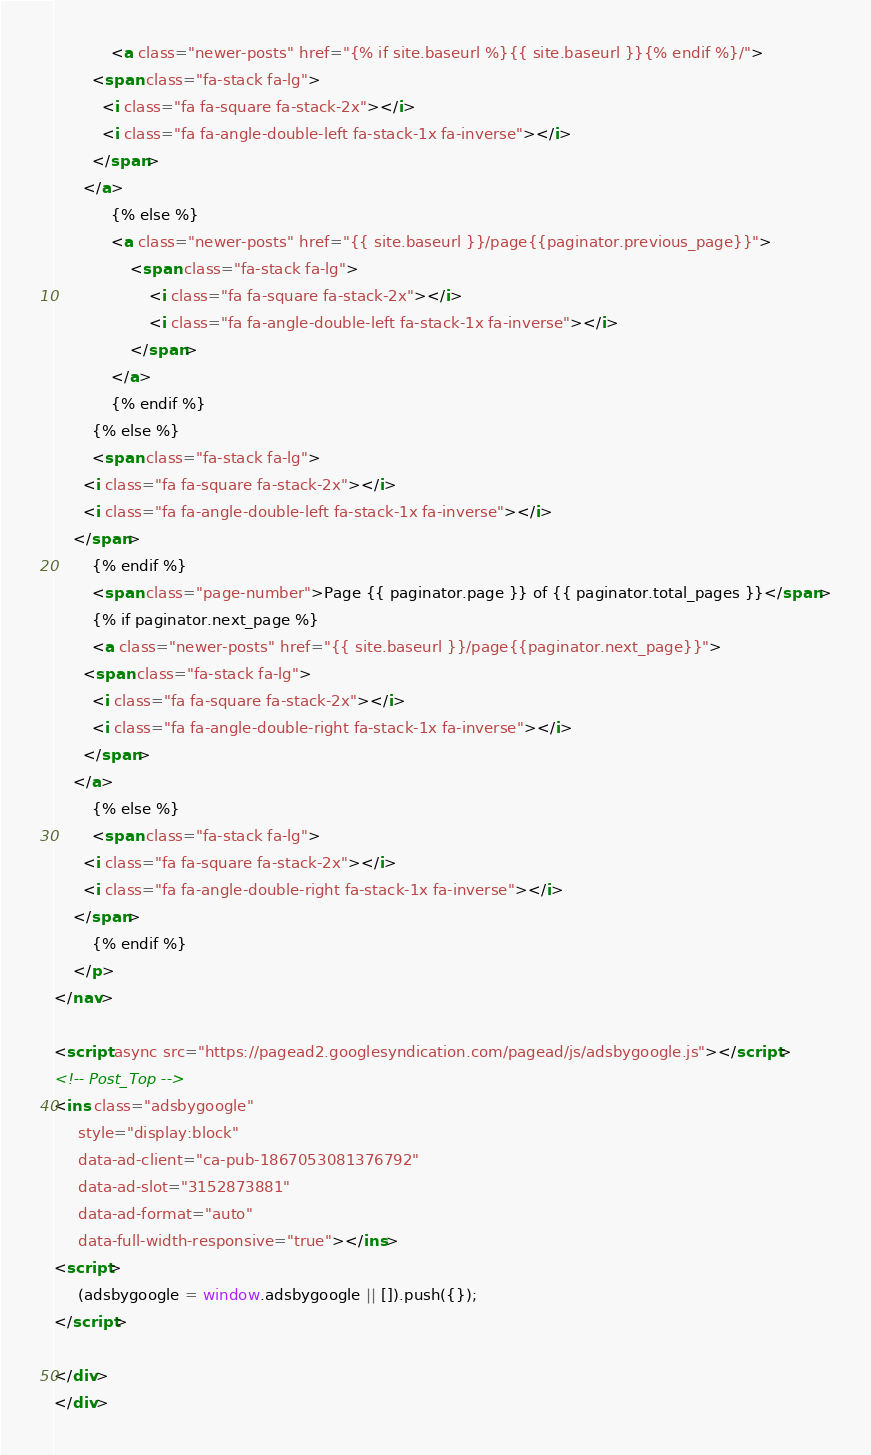Convert code to text. <code><loc_0><loc_0><loc_500><loc_500><_HTML_>			<a class="newer-posts" href="{% if site.baseurl %}{{ site.baseurl }}{% endif %}/">
        <span class="fa-stack fa-lg">
          <i class="fa fa-square fa-stack-2x"></i>
          <i class="fa fa-angle-double-left fa-stack-1x fa-inverse"></i>
        </span>
      </a>
			{% else %}
			<a class="newer-posts" href="{{ site.baseurl }}/page{{paginator.previous_page}}">
				<span class="fa-stack fa-lg">
					<i class="fa fa-square fa-stack-2x"></i>
					<i class="fa fa-angle-double-left fa-stack-1x fa-inverse"></i>
				</span>
			</a>
			{% endif %}
		{% else %}
		<span class="fa-stack fa-lg">
      <i class="fa fa-square fa-stack-2x"></i>
      <i class="fa fa-angle-double-left fa-stack-1x fa-inverse"></i>
    </span>
		{% endif %}
		<span class="page-number">Page {{ paginator.page }} of {{ paginator.total_pages }}</span>
		{% if paginator.next_page %}
		<a class="newer-posts" href="{{ site.baseurl }}/page{{paginator.next_page}}">
      <span class="fa-stack fa-lg">
        <i class="fa fa-square fa-stack-2x"></i>
        <i class="fa fa-angle-double-right fa-stack-1x fa-inverse"></i>
      </span>
    </a>
		{% else %}
		<span class="fa-stack fa-lg">
      <i class="fa fa-square fa-stack-2x"></i>
      <i class="fa fa-angle-double-right fa-stack-1x fa-inverse"></i>
    </span>
		{% endif %}
	</p>
</nav>

<script async src="https://pagead2.googlesyndication.com/pagead/js/adsbygoogle.js"></script>
<!-- Post_Top -->
<ins class="adsbygoogle"
     style="display:block"
     data-ad-client="ca-pub-1867053081376792"
     data-ad-slot="3152873881"
     data-ad-format="auto"
     data-full-width-responsive="true"></ins>
<script>
     (adsbygoogle = window.adsbygoogle || []).push({});
</script>

</div>
</div>
</code> 